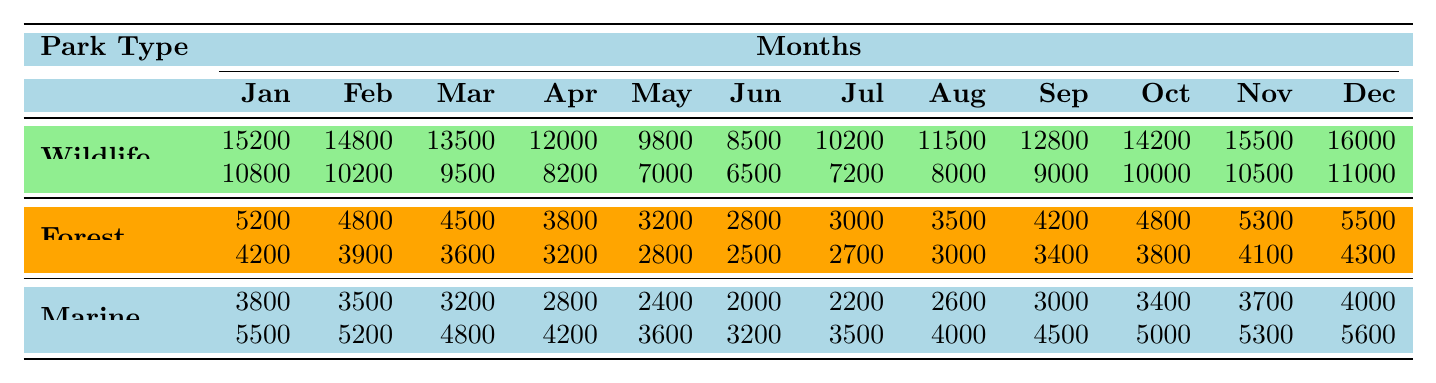What is the total number of visitors to Yala National Park in December? Looking at the table, for Yala National Park under the Wildlife category, the number of visitors in December is 16,000. Therefore, the total number of visitors in December is simply that number.
Answer: 16000 Which park type had the highest total number of visitors in October? In October, the totals for each park type in the table are: Wildlife (Yala: 14,200 + Udawalawe: 10,000 = 24,200), Forest (Sinharaja: 4,800 + Knuckles: 3,800 = 8,600), Marine (Pigeon Island: 3,400 + Hikkaduwa: 5,000 = 8,400). The Wildlife park type has the highest total of 24,200.
Answer: Wildlife How many visitors did Sinharaja Forest Reserve have in May? The table shows that Sinharaja Forest Reserve had 3,200 visitors in May.
Answer: 3200 What is the average number of visitors for Pigeon Island National Park over the entire year? The total number of visitors for Pigeon Island over the months is 3,800 + 3,500 + 3,200 + 2,800 + 2,400 + 2,000 + 2,200 + 2,600 + 3,000 + 3,400 + 3,700 + 4,000 = 30,400. There are 12 months, so the average is 30,400 / 12 = 2,533.33 (rounded down to 2,533 for conciseness).
Answer: 2533 Which month had the highest number of total visitors across all parks? To find this, sum the visitors for each month across all park types. January totals: 15,200 + 5,200 + 3,800 + 10,800 + 4,200 + 5,500 = 49,900, and similarly calculate for each month. The month with the highest total is December with 16,000 + 5,500 + 4,000 + 11,000 + 4,300 + 5,600 = 46,400. January had the highest at 49,900.
Answer: January Did more people visit Wildlife parks or Marine parks in June? The total visitors in June for Wildlife parks is 8,500 + 6,500 = 15,000, while for Marine parks it's 2,000 + 3,200 = 5,200. Clearly, more people visited Wildlife parks in June.
Answer: Yes Which forest park had the least number of visitors in April? From the table, Sinharaja Forest Reserve had 3,800 visitors in April, and Knuckles Mountain Range had 3,200. Therefore, Knuckles had the least visitors in April.
Answer: Knuckles Mountain Range If we were to rank the parks by total visitors in November, which park would come third? Calculate total visitors for November: Yala (15,500) + Udawalawe (10,500) + Sinharaja (5,300) + Knuckles (4,100) + Pigeon Island (3,700) + Hikkaduwa (5,300). Yala has the highest, Udawalawe second, and Sinharaja comes third with 5,300.
Answer: Sinharaja Forest Reserve 